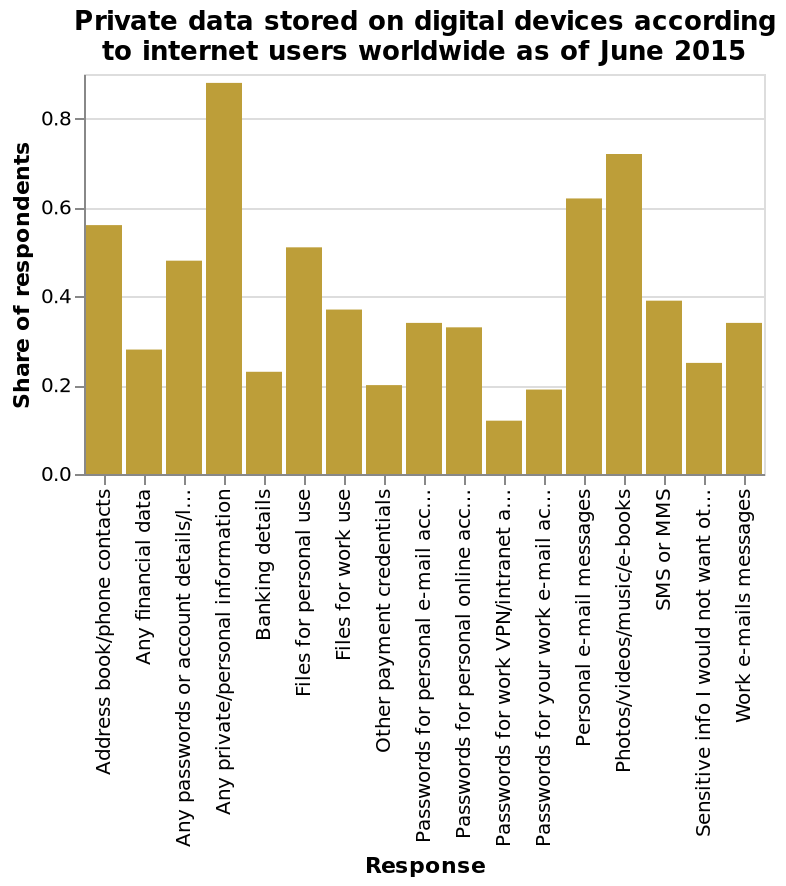<image>
What percentage of respondents store every category of data on digital devices?  Approximately 10% of respondents store every category of data on digital devices. What does the x-axis represent in the bar diagram?  The x-axis represents the response categories. What is the title or name given to this bar diagram? The bar diagram is titled "Private data stored on digital devices according to internet users worldwide as of June 2015." please enumerates aspects of the construction of the chart This bar diagram is called Private data stored on digital devices according to internet users worldwide as of June 2015. The y-axis plots Share of respondents while the x-axis plots Response. What does the bar diagram show in terms of data? The bar diagram displays the distribution of private data stored on digital devices as reported by internet users worldwide. Is the bar diagram titled "Public data stored on digital devices according to internet users worldwide as of June 2015"? No.The bar diagram is titled "Private data stored on digital devices according to internet users worldwide as of June 2015." 